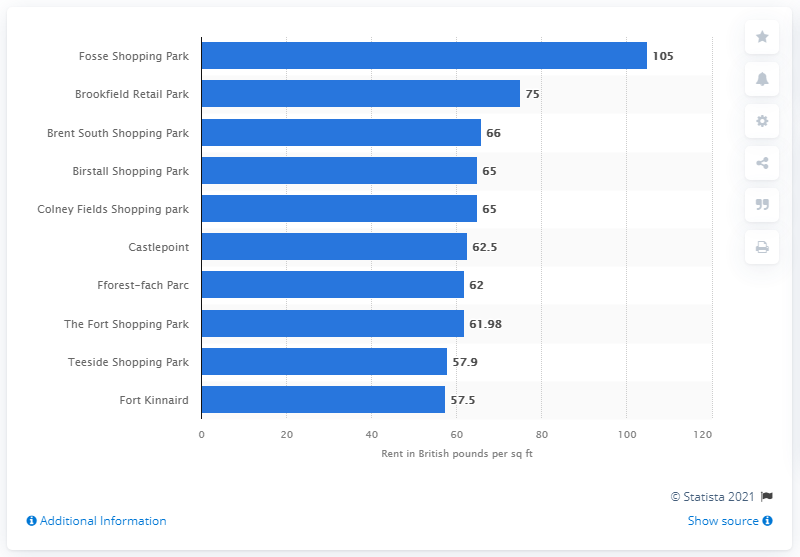Point out several critical features in this image. Fosse Shopping Park, a retail park in Leicester, was ranked first among all retail parks in the UK in terms of highest rents in 2019. 